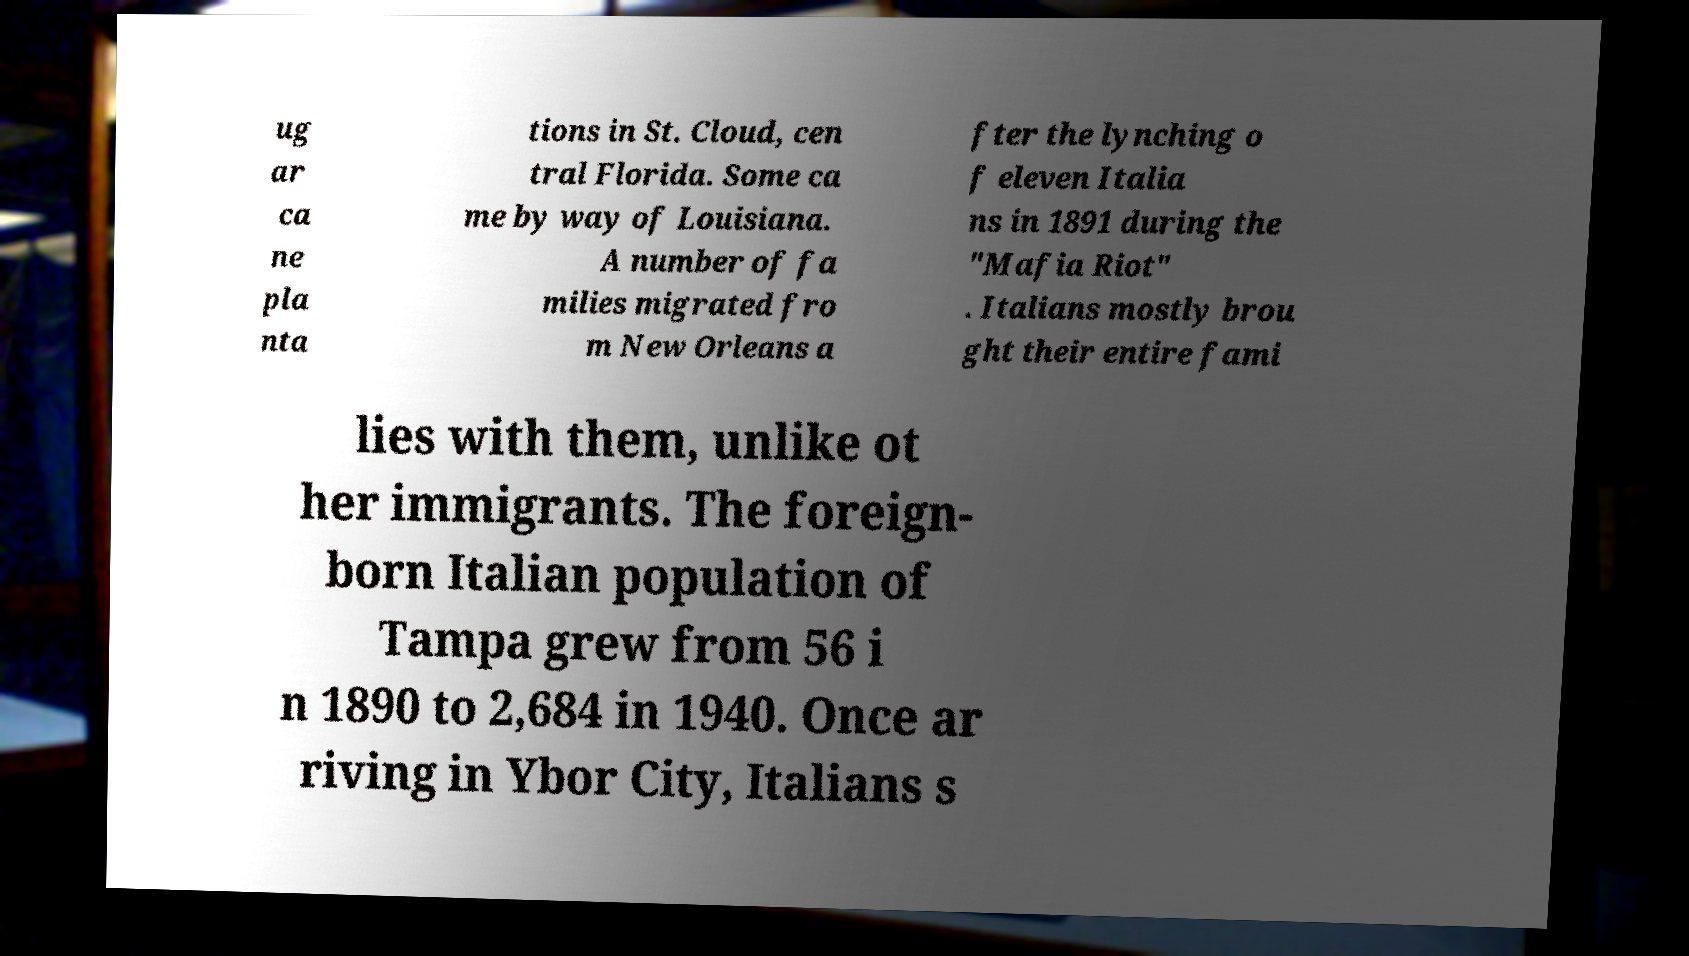Can you read and provide the text displayed in the image?This photo seems to have some interesting text. Can you extract and type it out for me? ug ar ca ne pla nta tions in St. Cloud, cen tral Florida. Some ca me by way of Louisiana. A number of fa milies migrated fro m New Orleans a fter the lynching o f eleven Italia ns in 1891 during the "Mafia Riot" . Italians mostly brou ght their entire fami lies with them, unlike ot her immigrants. The foreign- born Italian population of Tampa grew from 56 i n 1890 to 2,684 in 1940. Once ar riving in Ybor City, Italians s 